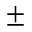<formula> <loc_0><loc_0><loc_500><loc_500>\pm</formula> 